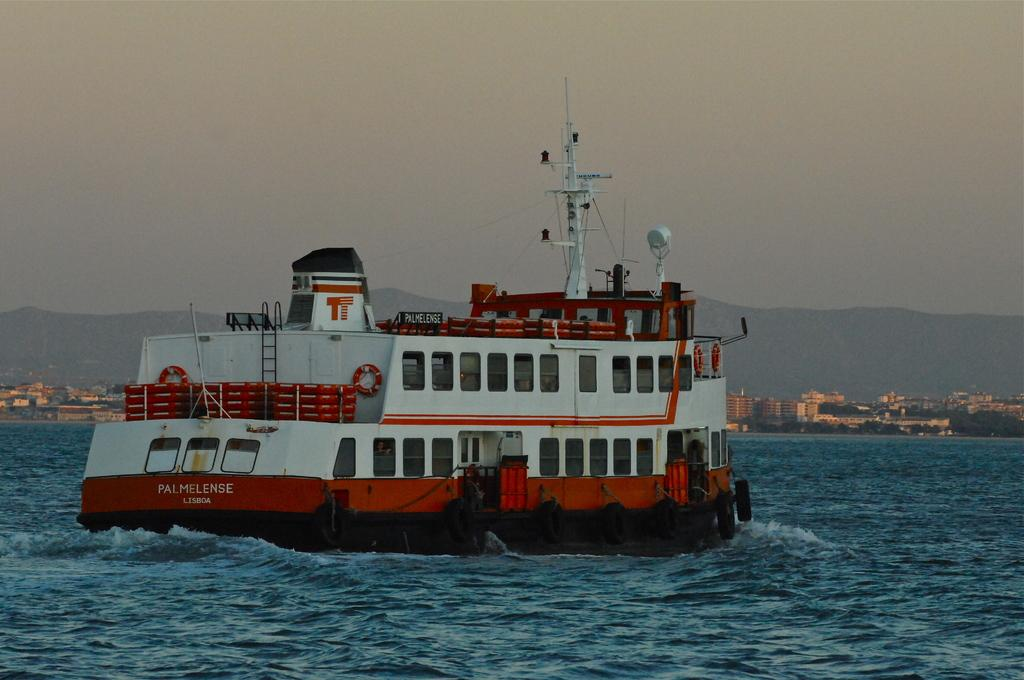What is the main subject in the center of the image? There is a ship in the center of the image. What is the ship doing in the image? The ship is sailing on the water. What can be seen in the background of the image? There are buildings and mountains in the background of the image. How would you describe the sky in the image? The sky is cloudy. What type of texture can be seen on the tank in the image? There is no tank present in the image; it features a ship sailing on the water. 